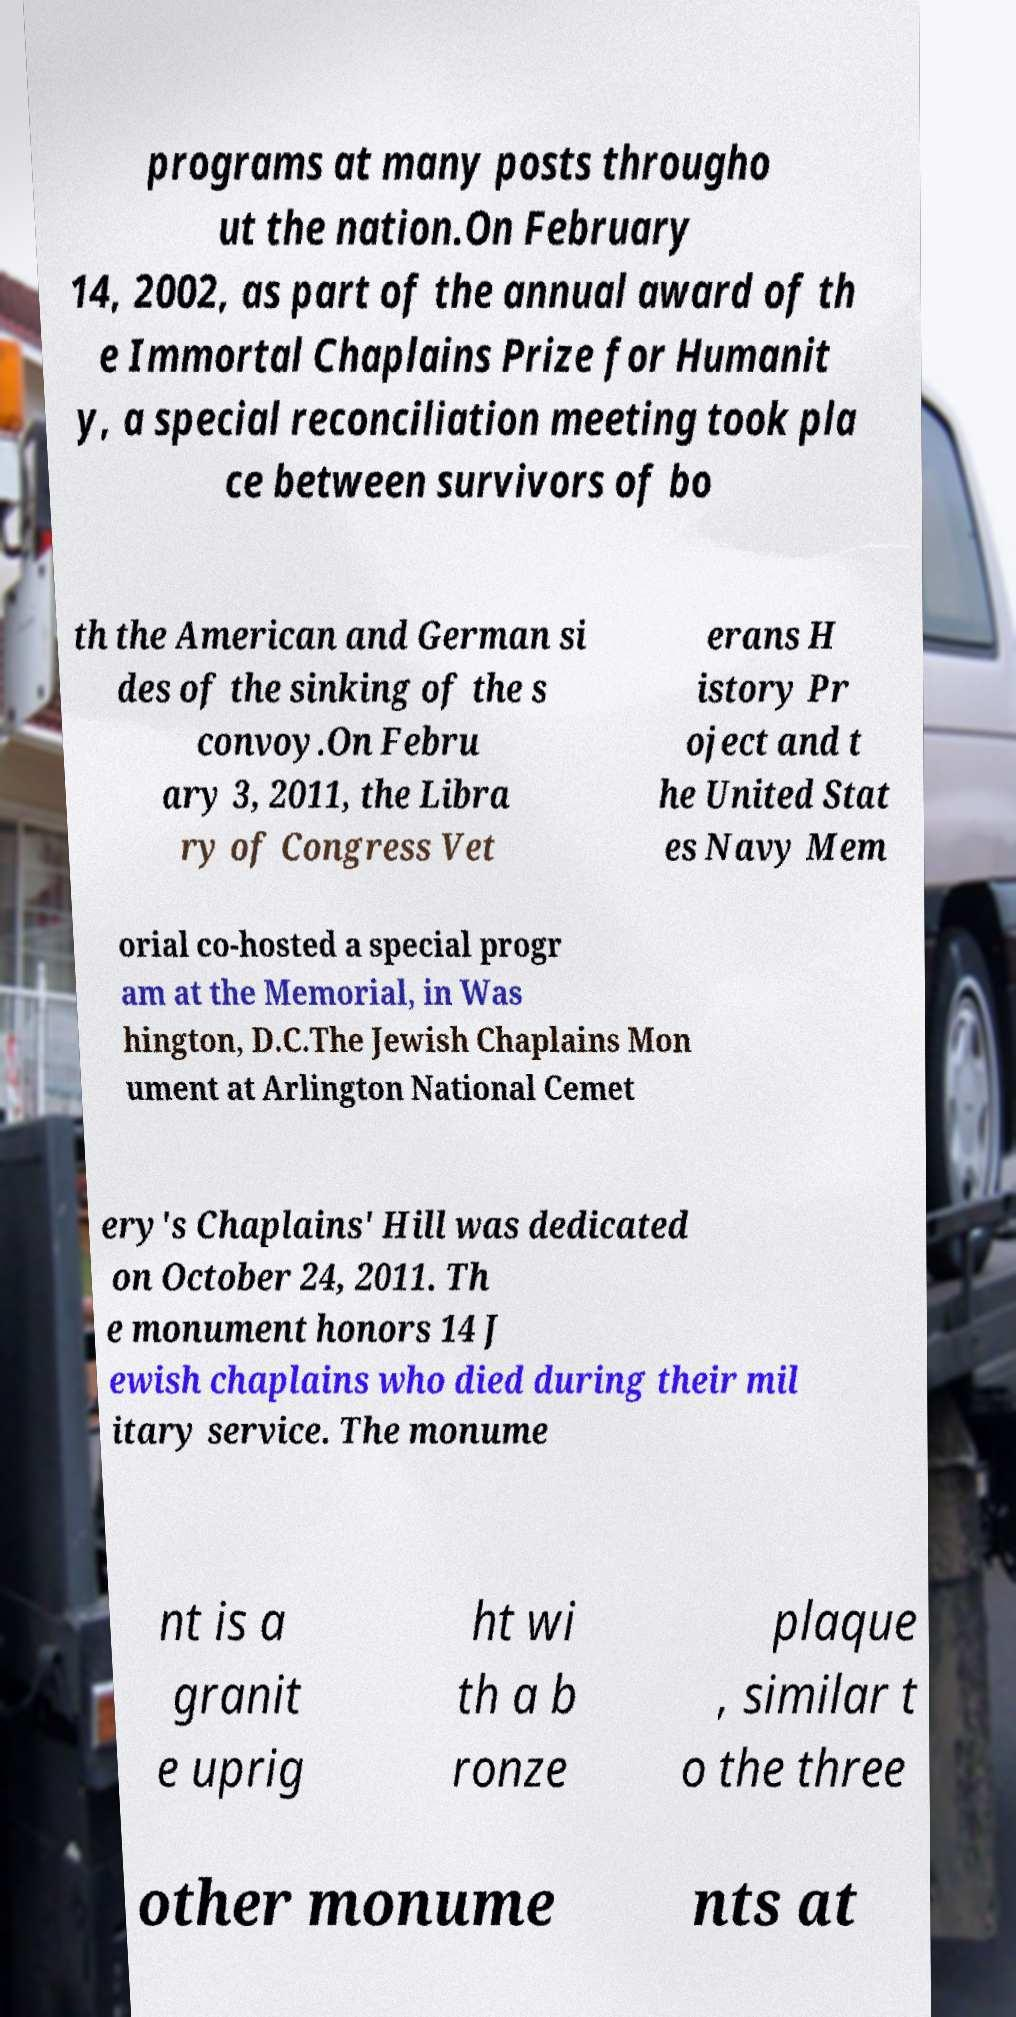Can you read and provide the text displayed in the image?This photo seems to have some interesting text. Can you extract and type it out for me? programs at many posts througho ut the nation.On February 14, 2002, as part of the annual award of th e Immortal Chaplains Prize for Humanit y, a special reconciliation meeting took pla ce between survivors of bo th the American and German si des of the sinking of the s convoy.On Febru ary 3, 2011, the Libra ry of Congress Vet erans H istory Pr oject and t he United Stat es Navy Mem orial co-hosted a special progr am at the Memorial, in Was hington, D.C.The Jewish Chaplains Mon ument at Arlington National Cemet ery's Chaplains' Hill was dedicated on October 24, 2011. Th e monument honors 14 J ewish chaplains who died during their mil itary service. The monume nt is a granit e uprig ht wi th a b ronze plaque , similar t o the three other monume nts at 